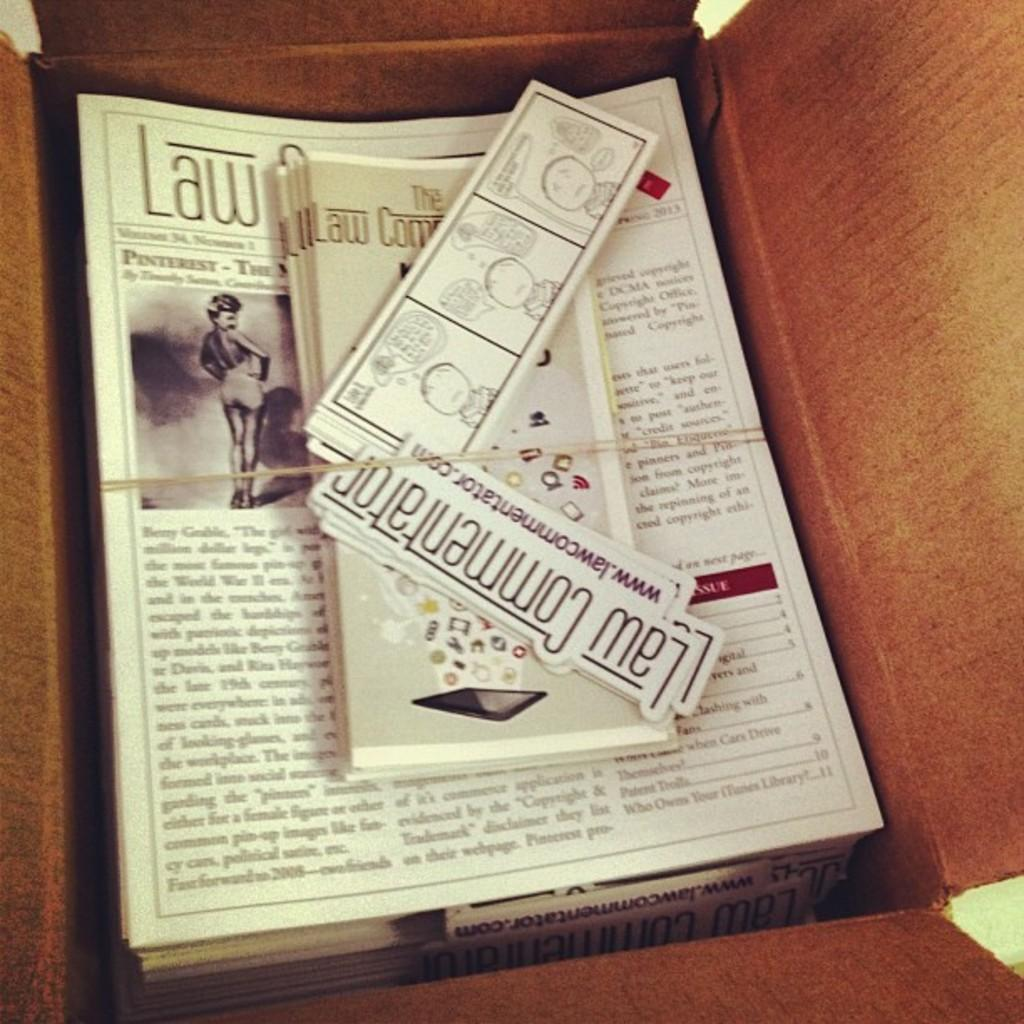<image>
Present a compact description of the photo's key features. Looking down into an opened box containing magazines, flyers and signs with the words Law Commentator on them. 